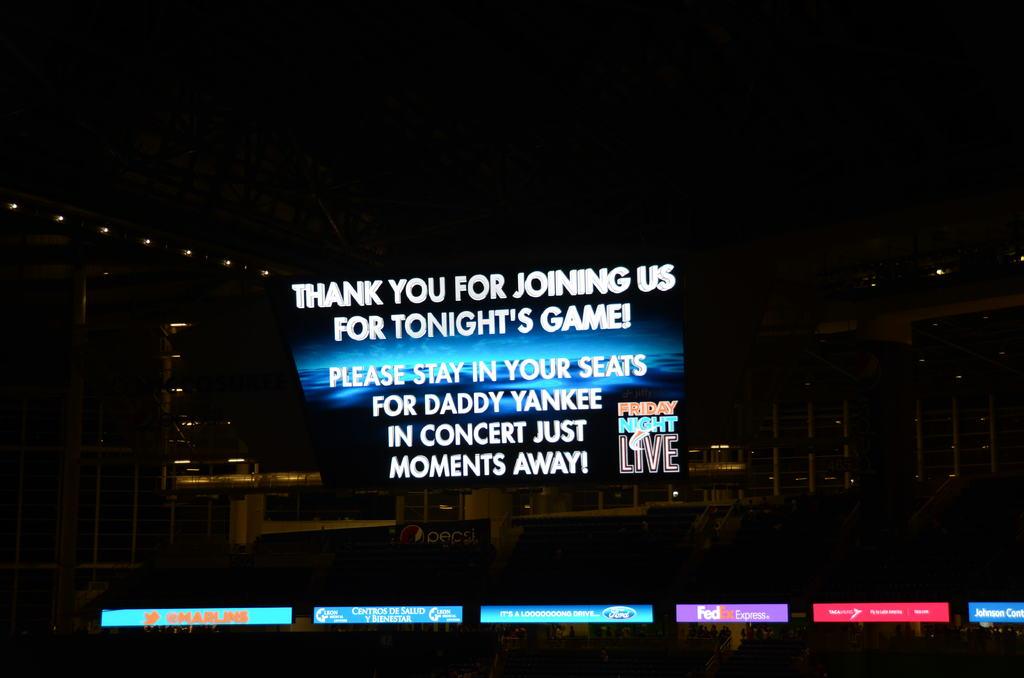Who will be singing at the concert?
Offer a terse response. Daddy yankee. What day of the week was this game?
Offer a terse response. Friday. 